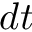<formula> <loc_0><loc_0><loc_500><loc_500>d t</formula> 